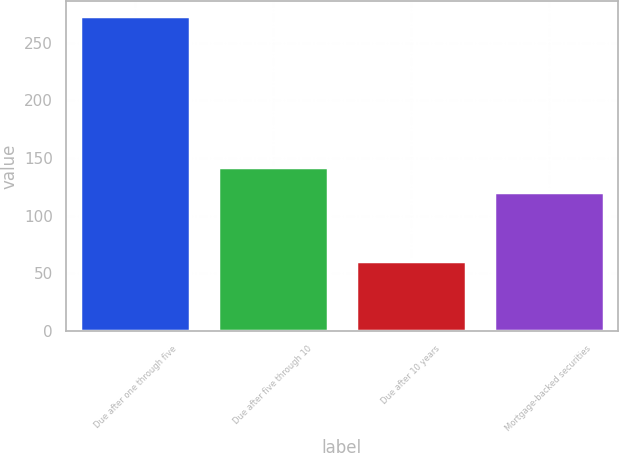Convert chart. <chart><loc_0><loc_0><loc_500><loc_500><bar_chart><fcel>Due after one through five<fcel>Due after five through 10<fcel>Due after 10 years<fcel>Mortgage-backed securities<nl><fcel>273<fcel>142.2<fcel>61<fcel>121<nl></chart> 